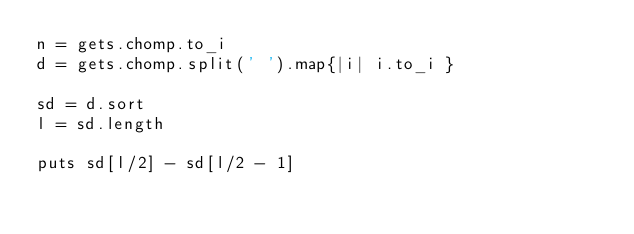<code> <loc_0><loc_0><loc_500><loc_500><_Ruby_>n = gets.chomp.to_i
d = gets.chomp.split(' ').map{|i| i.to_i }

sd = d.sort
l = sd.length

puts sd[l/2] - sd[l/2 - 1]
</code> 